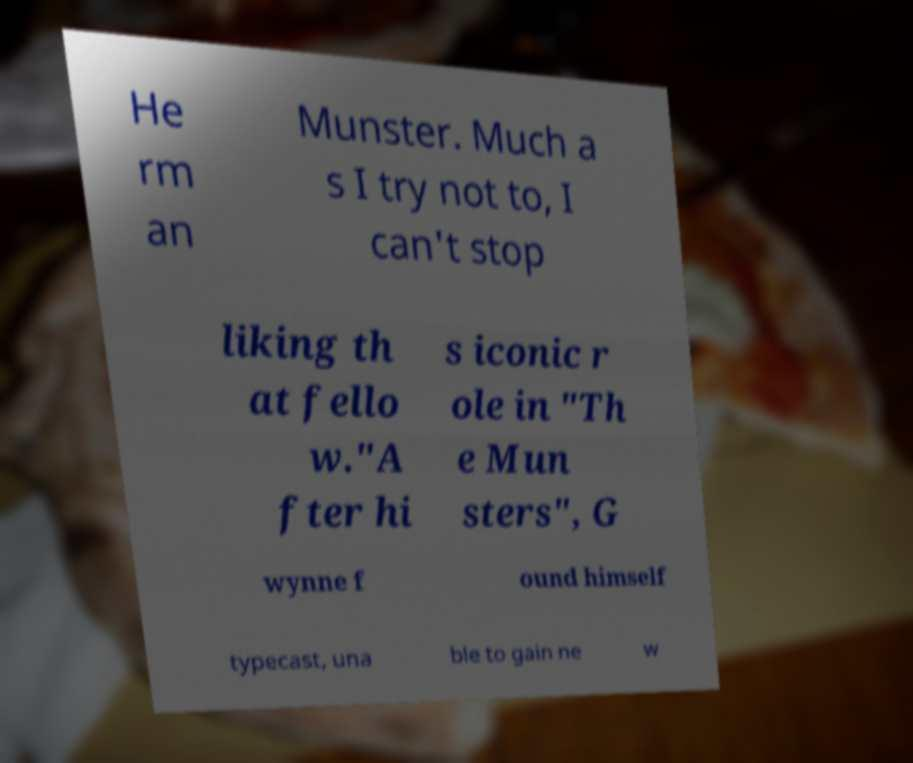I need the written content from this picture converted into text. Can you do that? He rm an Munster. Much a s I try not to, I can't stop liking th at fello w."A fter hi s iconic r ole in "Th e Mun sters", G wynne f ound himself typecast, una ble to gain ne w 